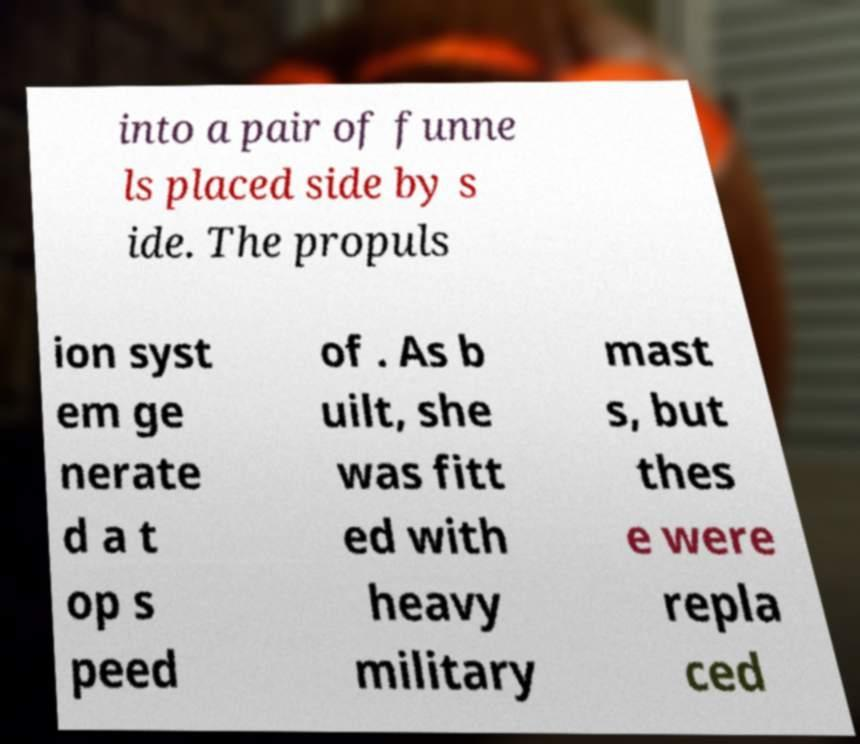Please identify and transcribe the text found in this image. into a pair of funne ls placed side by s ide. The propuls ion syst em ge nerate d a t op s peed of . As b uilt, she was fitt ed with heavy military mast s, but thes e were repla ced 